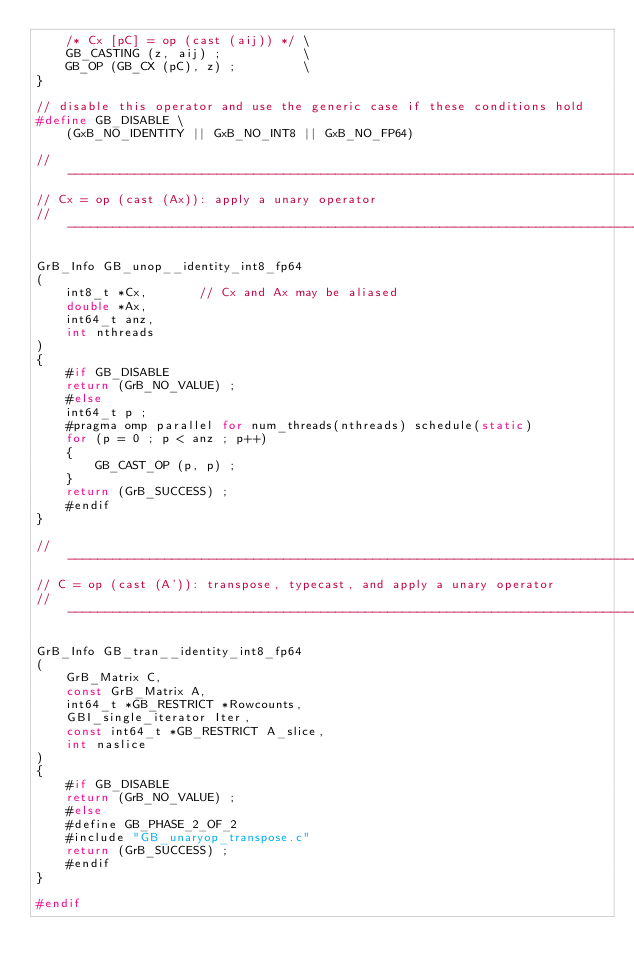<code> <loc_0><loc_0><loc_500><loc_500><_C_>    /* Cx [pC] = op (cast (aij)) */ \
    GB_CASTING (z, aij) ;           \
    GB_OP (GB_CX (pC), z) ;         \
}

// disable this operator and use the generic case if these conditions hold
#define GB_DISABLE \
    (GxB_NO_IDENTITY || GxB_NO_INT8 || GxB_NO_FP64)

//------------------------------------------------------------------------------
// Cx = op (cast (Ax)): apply a unary operator
//------------------------------------------------------------------------------

GrB_Info GB_unop__identity_int8_fp64
(
    int8_t *Cx,       // Cx and Ax may be aliased
    double *Ax,
    int64_t anz,
    int nthreads
)
{ 
    #if GB_DISABLE
    return (GrB_NO_VALUE) ;
    #else
    int64_t p ;
    #pragma omp parallel for num_threads(nthreads) schedule(static)
    for (p = 0 ; p < anz ; p++)
    {
        GB_CAST_OP (p, p) ;
    }
    return (GrB_SUCCESS) ;
    #endif
}

//------------------------------------------------------------------------------
// C = op (cast (A')): transpose, typecast, and apply a unary operator
//------------------------------------------------------------------------------

GrB_Info GB_tran__identity_int8_fp64
(
    GrB_Matrix C,
    const GrB_Matrix A,
    int64_t *GB_RESTRICT *Rowcounts,
    GBI_single_iterator Iter,
    const int64_t *GB_RESTRICT A_slice,
    int naslice
)
{ 
    #if GB_DISABLE
    return (GrB_NO_VALUE) ;
    #else
    #define GB_PHASE_2_OF_2
    #include "GB_unaryop_transpose.c"
    return (GrB_SUCCESS) ;
    #endif
}

#endif

</code> 